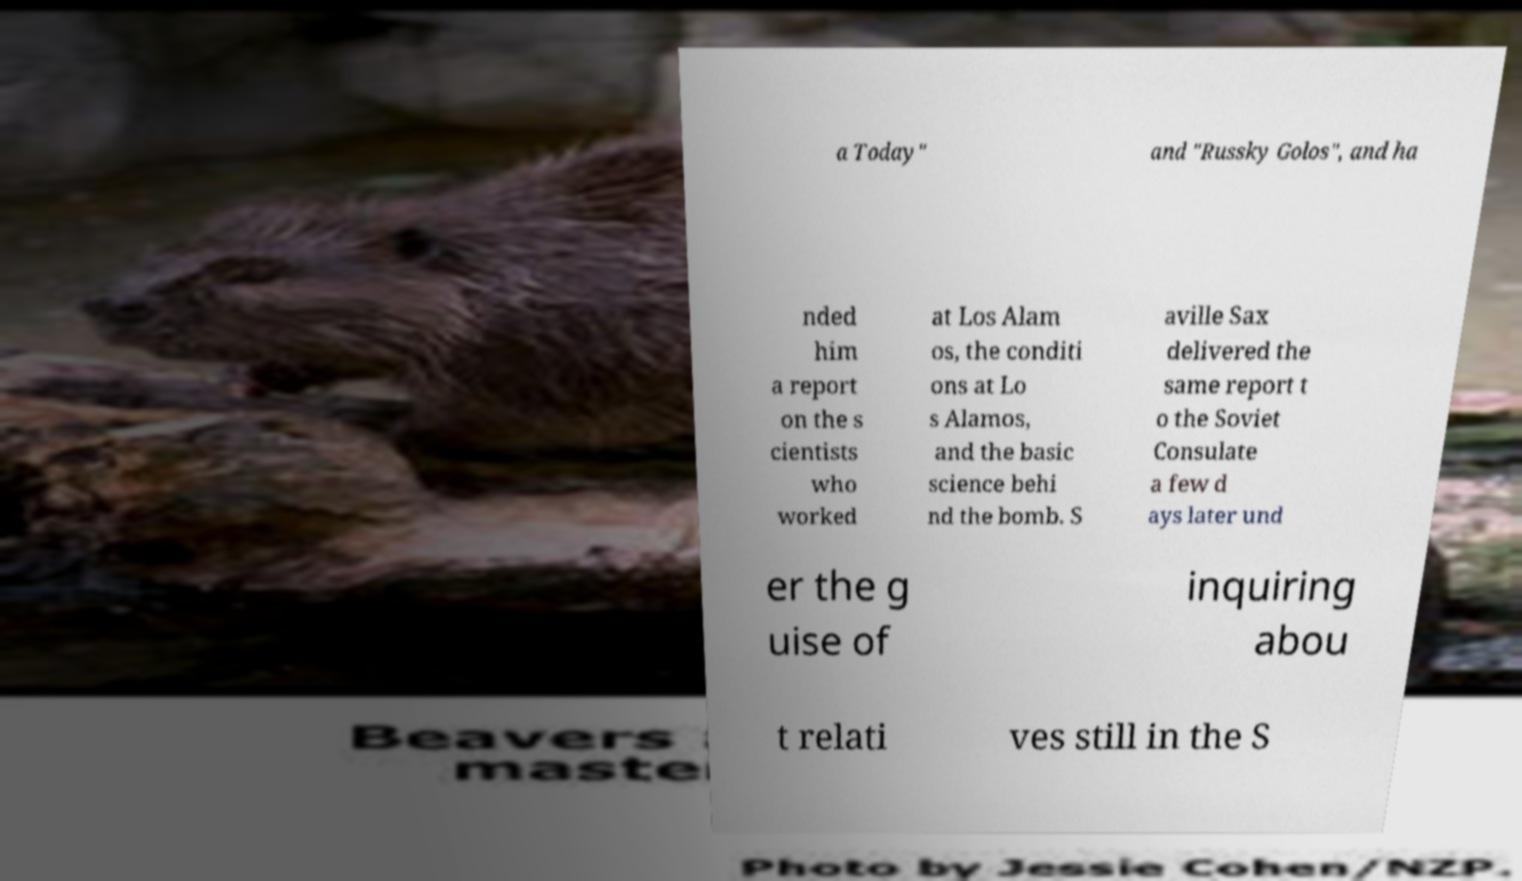Please read and relay the text visible in this image. What does it say? a Today" and "Russky Golos", and ha nded him a report on the s cientists who worked at Los Alam os, the conditi ons at Lo s Alamos, and the basic science behi nd the bomb. S aville Sax delivered the same report t o the Soviet Consulate a few d ays later und er the g uise of inquiring abou t relati ves still in the S 